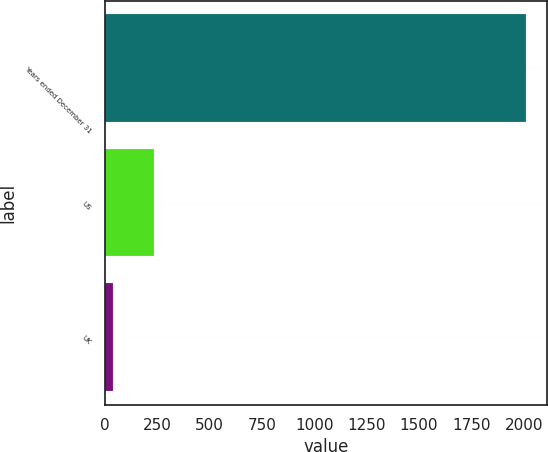Convert chart to OTSL. <chart><loc_0><loc_0><loc_500><loc_500><bar_chart><fcel>Years ended December 31<fcel>US<fcel>UK<nl><fcel>2009<fcel>235.1<fcel>38<nl></chart> 